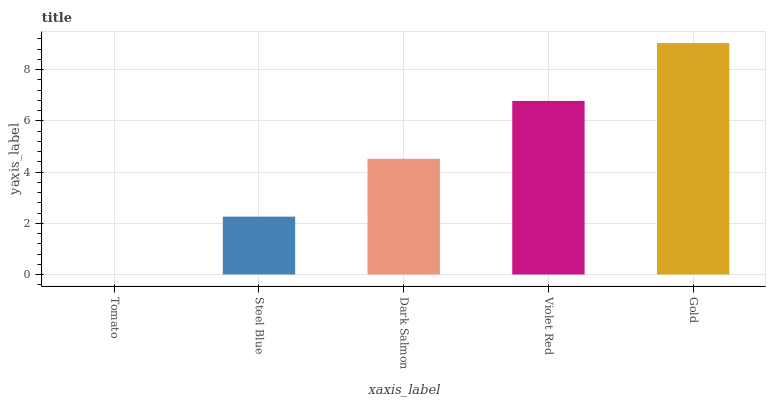Is Tomato the minimum?
Answer yes or no. Yes. Is Gold the maximum?
Answer yes or no. Yes. Is Steel Blue the minimum?
Answer yes or no. No. Is Steel Blue the maximum?
Answer yes or no. No. Is Steel Blue greater than Tomato?
Answer yes or no. Yes. Is Tomato less than Steel Blue?
Answer yes or no. Yes. Is Tomato greater than Steel Blue?
Answer yes or no. No. Is Steel Blue less than Tomato?
Answer yes or no. No. Is Dark Salmon the high median?
Answer yes or no. Yes. Is Dark Salmon the low median?
Answer yes or no. Yes. Is Tomato the high median?
Answer yes or no. No. Is Violet Red the low median?
Answer yes or no. No. 